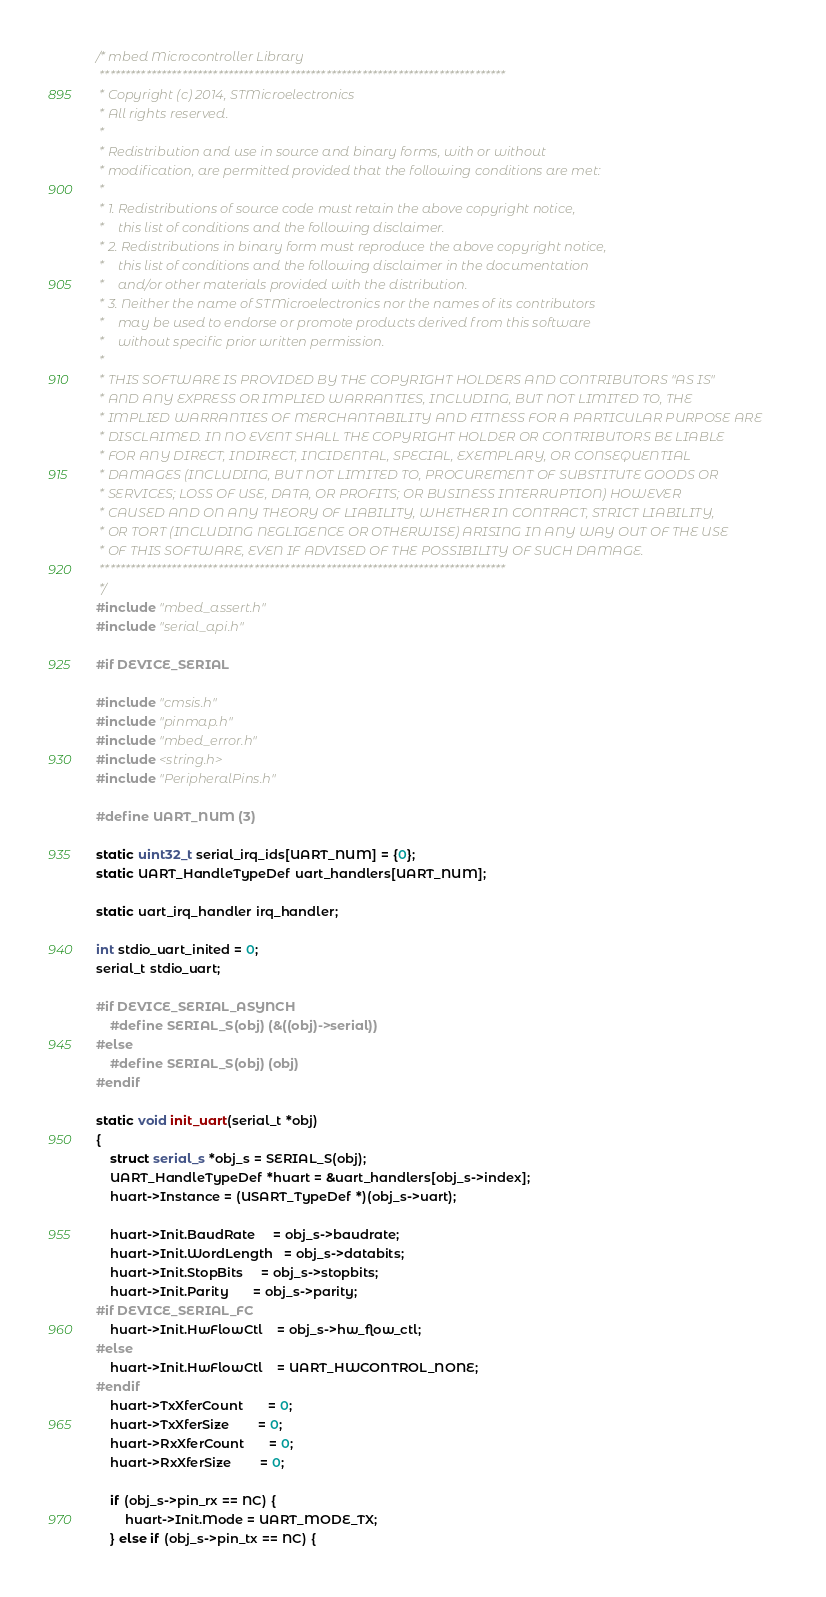<code> <loc_0><loc_0><loc_500><loc_500><_C_>/* mbed Microcontroller Library
 *******************************************************************************
 * Copyright (c) 2014, STMicroelectronics
 * All rights reserved.
 *
 * Redistribution and use in source and binary forms, with or without
 * modification, are permitted provided that the following conditions are met:
 *
 * 1. Redistributions of source code must retain the above copyright notice,
 *    this list of conditions and the following disclaimer.
 * 2. Redistributions in binary form must reproduce the above copyright notice,
 *    this list of conditions and the following disclaimer in the documentation
 *    and/or other materials provided with the distribution.
 * 3. Neither the name of STMicroelectronics nor the names of its contributors
 *    may be used to endorse or promote products derived from this software
 *    without specific prior written permission.
 *
 * THIS SOFTWARE IS PROVIDED BY THE COPYRIGHT HOLDERS AND CONTRIBUTORS "AS IS"
 * AND ANY EXPRESS OR IMPLIED WARRANTIES, INCLUDING, BUT NOT LIMITED TO, THE
 * IMPLIED WARRANTIES OF MERCHANTABILITY AND FITNESS FOR A PARTICULAR PURPOSE ARE
 * DISCLAIMED. IN NO EVENT SHALL THE COPYRIGHT HOLDER OR CONTRIBUTORS BE LIABLE
 * FOR ANY DIRECT, INDIRECT, INCIDENTAL, SPECIAL, EXEMPLARY, OR CONSEQUENTIAL
 * DAMAGES (INCLUDING, BUT NOT LIMITED TO, PROCUREMENT OF SUBSTITUTE GOODS OR
 * SERVICES; LOSS OF USE, DATA, OR PROFITS; OR BUSINESS INTERRUPTION) HOWEVER
 * CAUSED AND ON ANY THEORY OF LIABILITY, WHETHER IN CONTRACT, STRICT LIABILITY,
 * OR TORT (INCLUDING NEGLIGENCE OR OTHERWISE) ARISING IN ANY WAY OUT OF THE USE
 * OF THIS SOFTWARE, EVEN IF ADVISED OF THE POSSIBILITY OF SUCH DAMAGE.
 *******************************************************************************
 */
#include "mbed_assert.h"
#include "serial_api.h"

#if DEVICE_SERIAL

#include "cmsis.h"
#include "pinmap.h"
#include "mbed_error.h"
#include <string.h>
#include "PeripheralPins.h"

#define UART_NUM (3)

static uint32_t serial_irq_ids[UART_NUM] = {0};
static UART_HandleTypeDef uart_handlers[UART_NUM];

static uart_irq_handler irq_handler;

int stdio_uart_inited = 0;
serial_t stdio_uart;

#if DEVICE_SERIAL_ASYNCH
    #define SERIAL_S(obj) (&((obj)->serial))
#else
    #define SERIAL_S(obj) (obj)
#endif

static void init_uart(serial_t *obj)
{
    struct serial_s *obj_s = SERIAL_S(obj);
    UART_HandleTypeDef *huart = &uart_handlers[obj_s->index];
    huart->Instance = (USART_TypeDef *)(obj_s->uart);

    huart->Init.BaudRate     = obj_s->baudrate;
    huart->Init.WordLength   = obj_s->databits;
    huart->Init.StopBits     = obj_s->stopbits;
    huart->Init.Parity       = obj_s->parity;
#if DEVICE_SERIAL_FC
    huart->Init.HwFlowCtl    = obj_s->hw_flow_ctl;
#else
    huart->Init.HwFlowCtl    = UART_HWCONTROL_NONE;
#endif
    huart->TxXferCount       = 0;
    huart->TxXferSize        = 0;
    huart->RxXferCount       = 0;
    huart->RxXferSize        = 0;

    if (obj_s->pin_rx == NC) {
        huart->Init.Mode = UART_MODE_TX;
    } else if (obj_s->pin_tx == NC) {</code> 